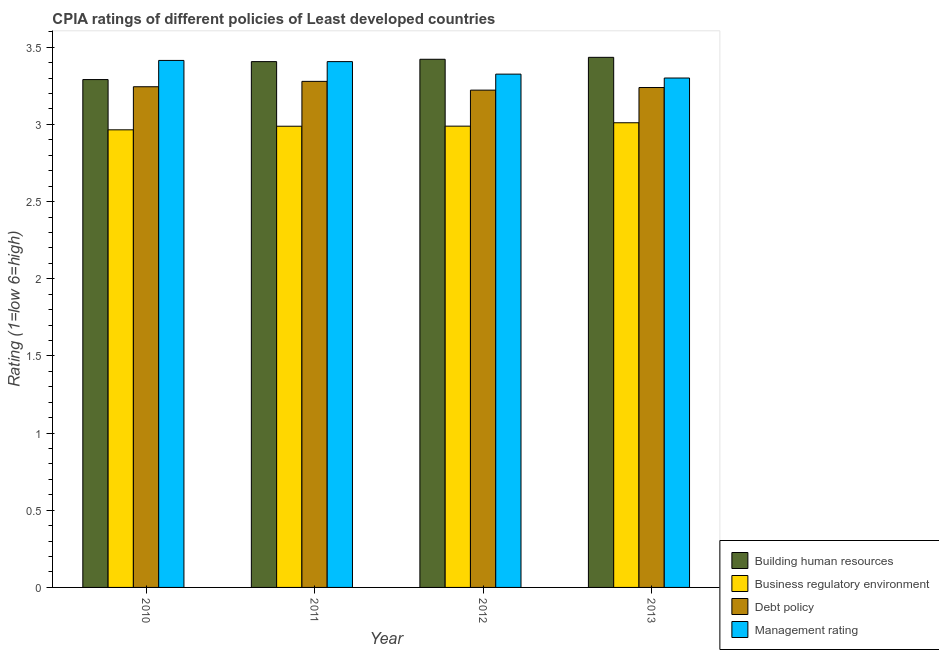How many groups of bars are there?
Ensure brevity in your answer.  4. Are the number of bars per tick equal to the number of legend labels?
Keep it short and to the point. Yes. How many bars are there on the 4th tick from the right?
Offer a terse response. 4. What is the label of the 3rd group of bars from the left?
Provide a succinct answer. 2012. What is the cpia rating of management in 2010?
Give a very brief answer. 3.41. Across all years, what is the maximum cpia rating of building human resources?
Make the answer very short. 3.43. Across all years, what is the minimum cpia rating of business regulatory environment?
Provide a short and direct response. 2.97. In which year was the cpia rating of business regulatory environment minimum?
Make the answer very short. 2010. What is the total cpia rating of management in the graph?
Provide a succinct answer. 13.45. What is the difference between the cpia rating of management in 2010 and that in 2013?
Make the answer very short. 0.11. What is the difference between the cpia rating of building human resources in 2012 and the cpia rating of management in 2013?
Give a very brief answer. -0.01. What is the average cpia rating of management per year?
Provide a short and direct response. 3.36. What is the ratio of the cpia rating of building human resources in 2010 to that in 2011?
Keep it short and to the point. 0.97. Is the difference between the cpia rating of management in 2012 and 2013 greater than the difference between the cpia rating of debt policy in 2012 and 2013?
Provide a short and direct response. No. What is the difference between the highest and the second highest cpia rating of management?
Your answer should be compact. 0.01. What is the difference between the highest and the lowest cpia rating of debt policy?
Provide a succinct answer. 0.06. In how many years, is the cpia rating of management greater than the average cpia rating of management taken over all years?
Offer a terse response. 2. Is the sum of the cpia rating of building human resources in 2011 and 2013 greater than the maximum cpia rating of business regulatory environment across all years?
Ensure brevity in your answer.  Yes. Is it the case that in every year, the sum of the cpia rating of building human resources and cpia rating of business regulatory environment is greater than the sum of cpia rating of management and cpia rating of debt policy?
Give a very brief answer. No. What does the 4th bar from the left in 2013 represents?
Ensure brevity in your answer.  Management rating. What does the 1st bar from the right in 2012 represents?
Make the answer very short. Management rating. Is it the case that in every year, the sum of the cpia rating of building human resources and cpia rating of business regulatory environment is greater than the cpia rating of debt policy?
Your response must be concise. Yes. Are all the bars in the graph horizontal?
Your answer should be very brief. No. Does the graph contain any zero values?
Provide a short and direct response. No. Does the graph contain grids?
Keep it short and to the point. No. How many legend labels are there?
Offer a terse response. 4. How are the legend labels stacked?
Your response must be concise. Vertical. What is the title of the graph?
Provide a short and direct response. CPIA ratings of different policies of Least developed countries. What is the label or title of the X-axis?
Ensure brevity in your answer.  Year. What is the Rating (1=low 6=high) in Building human resources in 2010?
Your answer should be very brief. 3.29. What is the Rating (1=low 6=high) of Business regulatory environment in 2010?
Your answer should be very brief. 2.97. What is the Rating (1=low 6=high) in Debt policy in 2010?
Your response must be concise. 3.24. What is the Rating (1=low 6=high) in Management rating in 2010?
Your answer should be very brief. 3.41. What is the Rating (1=low 6=high) in Building human resources in 2011?
Give a very brief answer. 3.41. What is the Rating (1=low 6=high) in Business regulatory environment in 2011?
Provide a short and direct response. 2.99. What is the Rating (1=low 6=high) of Debt policy in 2011?
Offer a very short reply. 3.28. What is the Rating (1=low 6=high) in Management rating in 2011?
Give a very brief answer. 3.41. What is the Rating (1=low 6=high) in Building human resources in 2012?
Ensure brevity in your answer.  3.42. What is the Rating (1=low 6=high) of Business regulatory environment in 2012?
Offer a terse response. 2.99. What is the Rating (1=low 6=high) in Debt policy in 2012?
Keep it short and to the point. 3.22. What is the Rating (1=low 6=high) in Management rating in 2012?
Keep it short and to the point. 3.33. What is the Rating (1=low 6=high) of Building human resources in 2013?
Offer a very short reply. 3.43. What is the Rating (1=low 6=high) of Business regulatory environment in 2013?
Your response must be concise. 3.01. What is the Rating (1=low 6=high) of Debt policy in 2013?
Your answer should be very brief. 3.24. What is the Rating (1=low 6=high) in Management rating in 2013?
Give a very brief answer. 3.3. Across all years, what is the maximum Rating (1=low 6=high) of Building human resources?
Your answer should be compact. 3.43. Across all years, what is the maximum Rating (1=low 6=high) of Business regulatory environment?
Your answer should be compact. 3.01. Across all years, what is the maximum Rating (1=low 6=high) in Debt policy?
Your response must be concise. 3.28. Across all years, what is the maximum Rating (1=low 6=high) of Management rating?
Provide a succinct answer. 3.41. Across all years, what is the minimum Rating (1=low 6=high) of Building human resources?
Provide a short and direct response. 3.29. Across all years, what is the minimum Rating (1=low 6=high) of Business regulatory environment?
Offer a terse response. 2.97. Across all years, what is the minimum Rating (1=low 6=high) in Debt policy?
Your answer should be compact. 3.22. Across all years, what is the minimum Rating (1=low 6=high) in Management rating?
Provide a succinct answer. 3.3. What is the total Rating (1=low 6=high) of Building human resources in the graph?
Ensure brevity in your answer.  13.55. What is the total Rating (1=low 6=high) in Business regulatory environment in the graph?
Your answer should be compact. 11.95. What is the total Rating (1=low 6=high) in Debt policy in the graph?
Provide a succinct answer. 12.98. What is the total Rating (1=low 6=high) of Management rating in the graph?
Provide a short and direct response. 13.45. What is the difference between the Rating (1=low 6=high) in Building human resources in 2010 and that in 2011?
Keep it short and to the point. -0.12. What is the difference between the Rating (1=low 6=high) of Business regulatory environment in 2010 and that in 2011?
Provide a succinct answer. -0.02. What is the difference between the Rating (1=low 6=high) of Debt policy in 2010 and that in 2011?
Provide a short and direct response. -0.03. What is the difference between the Rating (1=low 6=high) of Management rating in 2010 and that in 2011?
Your answer should be very brief. 0.01. What is the difference between the Rating (1=low 6=high) of Building human resources in 2010 and that in 2012?
Give a very brief answer. -0.13. What is the difference between the Rating (1=low 6=high) of Business regulatory environment in 2010 and that in 2012?
Provide a short and direct response. -0.02. What is the difference between the Rating (1=low 6=high) of Debt policy in 2010 and that in 2012?
Your response must be concise. 0.02. What is the difference between the Rating (1=low 6=high) of Management rating in 2010 and that in 2012?
Make the answer very short. 0.09. What is the difference between the Rating (1=low 6=high) of Building human resources in 2010 and that in 2013?
Ensure brevity in your answer.  -0.14. What is the difference between the Rating (1=low 6=high) of Business regulatory environment in 2010 and that in 2013?
Your response must be concise. -0.05. What is the difference between the Rating (1=low 6=high) in Debt policy in 2010 and that in 2013?
Your answer should be compact. 0.01. What is the difference between the Rating (1=low 6=high) of Management rating in 2010 and that in 2013?
Provide a succinct answer. 0.11. What is the difference between the Rating (1=low 6=high) of Building human resources in 2011 and that in 2012?
Your answer should be very brief. -0.02. What is the difference between the Rating (1=low 6=high) of Business regulatory environment in 2011 and that in 2012?
Give a very brief answer. -0. What is the difference between the Rating (1=low 6=high) of Debt policy in 2011 and that in 2012?
Keep it short and to the point. 0.06. What is the difference between the Rating (1=low 6=high) in Management rating in 2011 and that in 2012?
Offer a very short reply. 0.08. What is the difference between the Rating (1=low 6=high) in Building human resources in 2011 and that in 2013?
Your response must be concise. -0.03. What is the difference between the Rating (1=low 6=high) of Business regulatory environment in 2011 and that in 2013?
Keep it short and to the point. -0.02. What is the difference between the Rating (1=low 6=high) in Debt policy in 2011 and that in 2013?
Offer a very short reply. 0.04. What is the difference between the Rating (1=low 6=high) of Management rating in 2011 and that in 2013?
Give a very brief answer. 0.11. What is the difference between the Rating (1=low 6=high) in Building human resources in 2012 and that in 2013?
Provide a succinct answer. -0.01. What is the difference between the Rating (1=low 6=high) of Business regulatory environment in 2012 and that in 2013?
Keep it short and to the point. -0.02. What is the difference between the Rating (1=low 6=high) in Debt policy in 2012 and that in 2013?
Provide a succinct answer. -0.02. What is the difference between the Rating (1=low 6=high) of Management rating in 2012 and that in 2013?
Make the answer very short. 0.03. What is the difference between the Rating (1=low 6=high) in Building human resources in 2010 and the Rating (1=low 6=high) in Business regulatory environment in 2011?
Provide a short and direct response. 0.3. What is the difference between the Rating (1=low 6=high) in Building human resources in 2010 and the Rating (1=low 6=high) in Debt policy in 2011?
Offer a very short reply. 0.01. What is the difference between the Rating (1=low 6=high) in Building human resources in 2010 and the Rating (1=low 6=high) in Management rating in 2011?
Your answer should be compact. -0.12. What is the difference between the Rating (1=low 6=high) of Business regulatory environment in 2010 and the Rating (1=low 6=high) of Debt policy in 2011?
Offer a terse response. -0.31. What is the difference between the Rating (1=low 6=high) of Business regulatory environment in 2010 and the Rating (1=low 6=high) of Management rating in 2011?
Ensure brevity in your answer.  -0.44. What is the difference between the Rating (1=low 6=high) of Debt policy in 2010 and the Rating (1=low 6=high) of Management rating in 2011?
Your answer should be very brief. -0.16. What is the difference between the Rating (1=low 6=high) of Building human resources in 2010 and the Rating (1=low 6=high) of Business regulatory environment in 2012?
Offer a terse response. 0.3. What is the difference between the Rating (1=low 6=high) in Building human resources in 2010 and the Rating (1=low 6=high) in Debt policy in 2012?
Your answer should be very brief. 0.07. What is the difference between the Rating (1=low 6=high) in Building human resources in 2010 and the Rating (1=low 6=high) in Management rating in 2012?
Offer a very short reply. -0.04. What is the difference between the Rating (1=low 6=high) of Business regulatory environment in 2010 and the Rating (1=low 6=high) of Debt policy in 2012?
Your answer should be very brief. -0.26. What is the difference between the Rating (1=low 6=high) in Business regulatory environment in 2010 and the Rating (1=low 6=high) in Management rating in 2012?
Offer a very short reply. -0.36. What is the difference between the Rating (1=low 6=high) of Debt policy in 2010 and the Rating (1=low 6=high) of Management rating in 2012?
Ensure brevity in your answer.  -0.08. What is the difference between the Rating (1=low 6=high) in Building human resources in 2010 and the Rating (1=low 6=high) in Business regulatory environment in 2013?
Provide a succinct answer. 0.28. What is the difference between the Rating (1=low 6=high) in Building human resources in 2010 and the Rating (1=low 6=high) in Debt policy in 2013?
Offer a terse response. 0.05. What is the difference between the Rating (1=low 6=high) in Building human resources in 2010 and the Rating (1=low 6=high) in Management rating in 2013?
Make the answer very short. -0.01. What is the difference between the Rating (1=low 6=high) of Business regulatory environment in 2010 and the Rating (1=low 6=high) of Debt policy in 2013?
Provide a short and direct response. -0.27. What is the difference between the Rating (1=low 6=high) of Business regulatory environment in 2010 and the Rating (1=low 6=high) of Management rating in 2013?
Give a very brief answer. -0.34. What is the difference between the Rating (1=low 6=high) of Debt policy in 2010 and the Rating (1=low 6=high) of Management rating in 2013?
Your response must be concise. -0.06. What is the difference between the Rating (1=low 6=high) of Building human resources in 2011 and the Rating (1=low 6=high) of Business regulatory environment in 2012?
Make the answer very short. 0.42. What is the difference between the Rating (1=low 6=high) in Building human resources in 2011 and the Rating (1=low 6=high) in Debt policy in 2012?
Offer a terse response. 0.18. What is the difference between the Rating (1=low 6=high) in Building human resources in 2011 and the Rating (1=low 6=high) in Management rating in 2012?
Give a very brief answer. 0.08. What is the difference between the Rating (1=low 6=high) of Business regulatory environment in 2011 and the Rating (1=low 6=high) of Debt policy in 2012?
Provide a succinct answer. -0.23. What is the difference between the Rating (1=low 6=high) in Business regulatory environment in 2011 and the Rating (1=low 6=high) in Management rating in 2012?
Offer a very short reply. -0.34. What is the difference between the Rating (1=low 6=high) in Debt policy in 2011 and the Rating (1=low 6=high) in Management rating in 2012?
Your response must be concise. -0.05. What is the difference between the Rating (1=low 6=high) of Building human resources in 2011 and the Rating (1=low 6=high) of Business regulatory environment in 2013?
Provide a short and direct response. 0.4. What is the difference between the Rating (1=low 6=high) of Building human resources in 2011 and the Rating (1=low 6=high) of Debt policy in 2013?
Your response must be concise. 0.17. What is the difference between the Rating (1=low 6=high) in Building human resources in 2011 and the Rating (1=low 6=high) in Management rating in 2013?
Give a very brief answer. 0.11. What is the difference between the Rating (1=low 6=high) of Business regulatory environment in 2011 and the Rating (1=low 6=high) of Debt policy in 2013?
Your response must be concise. -0.25. What is the difference between the Rating (1=low 6=high) of Business regulatory environment in 2011 and the Rating (1=low 6=high) of Management rating in 2013?
Provide a short and direct response. -0.31. What is the difference between the Rating (1=low 6=high) of Debt policy in 2011 and the Rating (1=low 6=high) of Management rating in 2013?
Keep it short and to the point. -0.02. What is the difference between the Rating (1=low 6=high) of Building human resources in 2012 and the Rating (1=low 6=high) of Business regulatory environment in 2013?
Ensure brevity in your answer.  0.41. What is the difference between the Rating (1=low 6=high) of Building human resources in 2012 and the Rating (1=low 6=high) of Debt policy in 2013?
Offer a very short reply. 0.18. What is the difference between the Rating (1=low 6=high) in Building human resources in 2012 and the Rating (1=low 6=high) in Management rating in 2013?
Ensure brevity in your answer.  0.12. What is the difference between the Rating (1=low 6=high) in Business regulatory environment in 2012 and the Rating (1=low 6=high) in Debt policy in 2013?
Offer a terse response. -0.25. What is the difference between the Rating (1=low 6=high) of Business regulatory environment in 2012 and the Rating (1=low 6=high) of Management rating in 2013?
Offer a terse response. -0.31. What is the difference between the Rating (1=low 6=high) of Debt policy in 2012 and the Rating (1=low 6=high) of Management rating in 2013?
Ensure brevity in your answer.  -0.08. What is the average Rating (1=low 6=high) of Building human resources per year?
Your response must be concise. 3.39. What is the average Rating (1=low 6=high) in Business regulatory environment per year?
Your answer should be very brief. 2.99. What is the average Rating (1=low 6=high) of Debt policy per year?
Ensure brevity in your answer.  3.25. What is the average Rating (1=low 6=high) of Management rating per year?
Offer a terse response. 3.36. In the year 2010, what is the difference between the Rating (1=low 6=high) in Building human resources and Rating (1=low 6=high) in Business regulatory environment?
Keep it short and to the point. 0.33. In the year 2010, what is the difference between the Rating (1=low 6=high) in Building human resources and Rating (1=low 6=high) in Debt policy?
Provide a short and direct response. 0.05. In the year 2010, what is the difference between the Rating (1=low 6=high) of Building human resources and Rating (1=low 6=high) of Management rating?
Your answer should be compact. -0.12. In the year 2010, what is the difference between the Rating (1=low 6=high) in Business regulatory environment and Rating (1=low 6=high) in Debt policy?
Your answer should be very brief. -0.28. In the year 2010, what is the difference between the Rating (1=low 6=high) in Business regulatory environment and Rating (1=low 6=high) in Management rating?
Give a very brief answer. -0.45. In the year 2010, what is the difference between the Rating (1=low 6=high) in Debt policy and Rating (1=low 6=high) in Management rating?
Provide a succinct answer. -0.17. In the year 2011, what is the difference between the Rating (1=low 6=high) of Building human resources and Rating (1=low 6=high) of Business regulatory environment?
Give a very brief answer. 0.42. In the year 2011, what is the difference between the Rating (1=low 6=high) in Building human resources and Rating (1=low 6=high) in Debt policy?
Keep it short and to the point. 0.13. In the year 2011, what is the difference between the Rating (1=low 6=high) in Building human resources and Rating (1=low 6=high) in Management rating?
Offer a very short reply. 0. In the year 2011, what is the difference between the Rating (1=low 6=high) in Business regulatory environment and Rating (1=low 6=high) in Debt policy?
Provide a succinct answer. -0.29. In the year 2011, what is the difference between the Rating (1=low 6=high) in Business regulatory environment and Rating (1=low 6=high) in Management rating?
Provide a succinct answer. -0.42. In the year 2011, what is the difference between the Rating (1=low 6=high) of Debt policy and Rating (1=low 6=high) of Management rating?
Ensure brevity in your answer.  -0.13. In the year 2012, what is the difference between the Rating (1=low 6=high) in Building human resources and Rating (1=low 6=high) in Business regulatory environment?
Your answer should be very brief. 0.43. In the year 2012, what is the difference between the Rating (1=low 6=high) of Building human resources and Rating (1=low 6=high) of Debt policy?
Provide a short and direct response. 0.2. In the year 2012, what is the difference between the Rating (1=low 6=high) in Building human resources and Rating (1=low 6=high) in Management rating?
Provide a short and direct response. 0.1. In the year 2012, what is the difference between the Rating (1=low 6=high) in Business regulatory environment and Rating (1=low 6=high) in Debt policy?
Provide a succinct answer. -0.23. In the year 2012, what is the difference between the Rating (1=low 6=high) in Business regulatory environment and Rating (1=low 6=high) in Management rating?
Ensure brevity in your answer.  -0.34. In the year 2012, what is the difference between the Rating (1=low 6=high) of Debt policy and Rating (1=low 6=high) of Management rating?
Offer a very short reply. -0.1. In the year 2013, what is the difference between the Rating (1=low 6=high) in Building human resources and Rating (1=low 6=high) in Business regulatory environment?
Ensure brevity in your answer.  0.42. In the year 2013, what is the difference between the Rating (1=low 6=high) of Building human resources and Rating (1=low 6=high) of Debt policy?
Make the answer very short. 0.2. In the year 2013, what is the difference between the Rating (1=low 6=high) in Building human resources and Rating (1=low 6=high) in Management rating?
Offer a terse response. 0.13. In the year 2013, what is the difference between the Rating (1=low 6=high) of Business regulatory environment and Rating (1=low 6=high) of Debt policy?
Your answer should be compact. -0.23. In the year 2013, what is the difference between the Rating (1=low 6=high) in Business regulatory environment and Rating (1=low 6=high) in Management rating?
Make the answer very short. -0.29. In the year 2013, what is the difference between the Rating (1=low 6=high) in Debt policy and Rating (1=low 6=high) in Management rating?
Your answer should be compact. -0.06. What is the ratio of the Rating (1=low 6=high) of Building human resources in 2010 to that in 2011?
Your answer should be very brief. 0.97. What is the ratio of the Rating (1=low 6=high) of Business regulatory environment in 2010 to that in 2011?
Offer a very short reply. 0.99. What is the ratio of the Rating (1=low 6=high) in Debt policy in 2010 to that in 2011?
Your response must be concise. 0.99. What is the ratio of the Rating (1=low 6=high) of Management rating in 2010 to that in 2011?
Your answer should be compact. 1. What is the ratio of the Rating (1=low 6=high) of Building human resources in 2010 to that in 2012?
Make the answer very short. 0.96. What is the ratio of the Rating (1=low 6=high) of Business regulatory environment in 2010 to that in 2012?
Offer a very short reply. 0.99. What is the ratio of the Rating (1=low 6=high) of Debt policy in 2010 to that in 2012?
Your answer should be very brief. 1.01. What is the ratio of the Rating (1=low 6=high) of Management rating in 2010 to that in 2012?
Your answer should be very brief. 1.03. What is the ratio of the Rating (1=low 6=high) of Building human resources in 2010 to that in 2013?
Your answer should be very brief. 0.96. What is the ratio of the Rating (1=low 6=high) of Business regulatory environment in 2010 to that in 2013?
Your answer should be very brief. 0.98. What is the ratio of the Rating (1=low 6=high) of Management rating in 2010 to that in 2013?
Offer a terse response. 1.03. What is the ratio of the Rating (1=low 6=high) in Building human resources in 2011 to that in 2012?
Provide a short and direct response. 1. What is the ratio of the Rating (1=low 6=high) of Debt policy in 2011 to that in 2012?
Provide a succinct answer. 1.02. What is the ratio of the Rating (1=low 6=high) of Management rating in 2011 to that in 2012?
Keep it short and to the point. 1.02. What is the ratio of the Rating (1=low 6=high) in Business regulatory environment in 2011 to that in 2013?
Keep it short and to the point. 0.99. What is the ratio of the Rating (1=low 6=high) of Debt policy in 2011 to that in 2013?
Provide a short and direct response. 1.01. What is the ratio of the Rating (1=low 6=high) in Management rating in 2011 to that in 2013?
Your answer should be very brief. 1.03. What is the ratio of the Rating (1=low 6=high) of Debt policy in 2012 to that in 2013?
Offer a very short reply. 0.99. What is the ratio of the Rating (1=low 6=high) in Management rating in 2012 to that in 2013?
Give a very brief answer. 1.01. What is the difference between the highest and the second highest Rating (1=low 6=high) of Building human resources?
Your answer should be compact. 0.01. What is the difference between the highest and the second highest Rating (1=low 6=high) of Business regulatory environment?
Give a very brief answer. 0.02. What is the difference between the highest and the second highest Rating (1=low 6=high) in Debt policy?
Give a very brief answer. 0.03. What is the difference between the highest and the second highest Rating (1=low 6=high) of Management rating?
Offer a very short reply. 0.01. What is the difference between the highest and the lowest Rating (1=low 6=high) of Building human resources?
Provide a succinct answer. 0.14. What is the difference between the highest and the lowest Rating (1=low 6=high) in Business regulatory environment?
Give a very brief answer. 0.05. What is the difference between the highest and the lowest Rating (1=low 6=high) of Debt policy?
Your response must be concise. 0.06. What is the difference between the highest and the lowest Rating (1=low 6=high) of Management rating?
Keep it short and to the point. 0.11. 